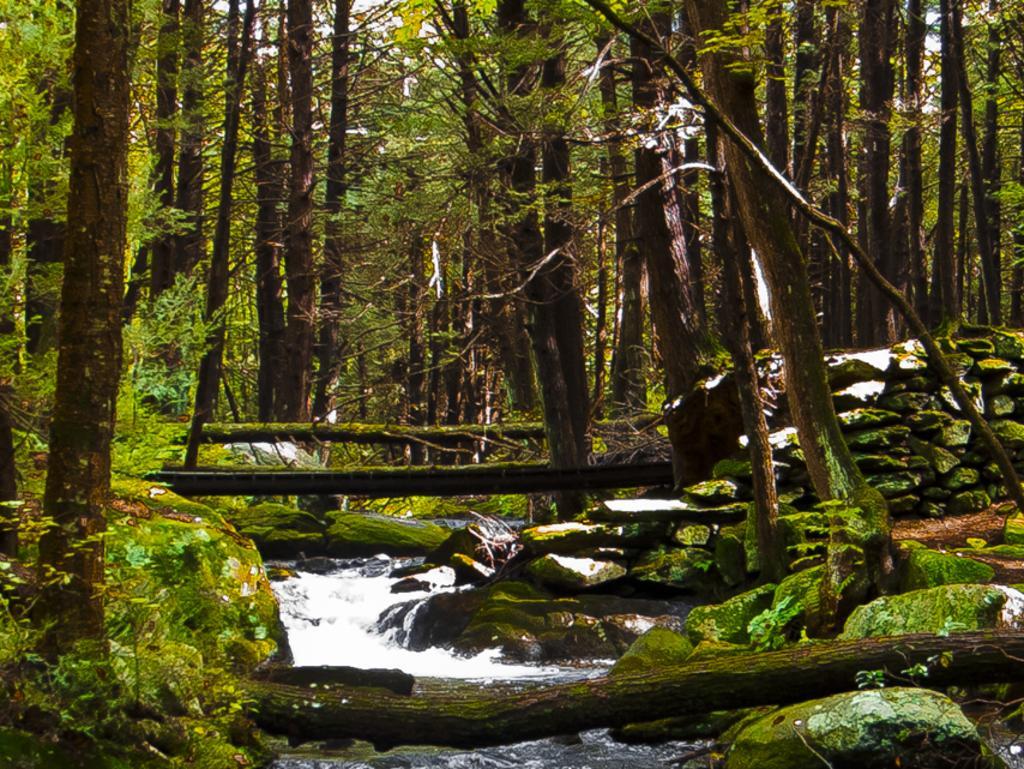How would you summarize this image in a sentence or two? In this image we can see many trees. There are few plants in the image. We can see the algae on the rock. There is a water in the image. 